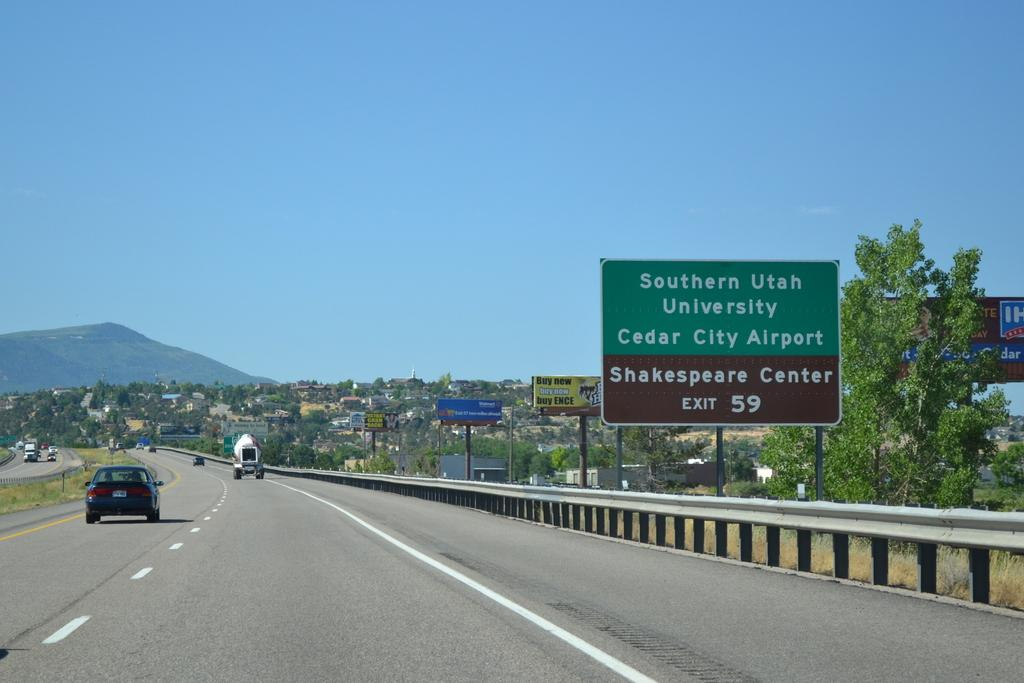<image>
Provide a brief description of the given image. A sign displaying the Shakespeare Center is at exit 59 